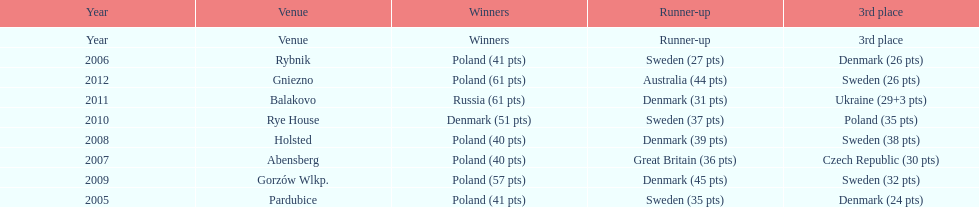In which most recent year did the 3rd place finisher score less than 25 points? 2005. 